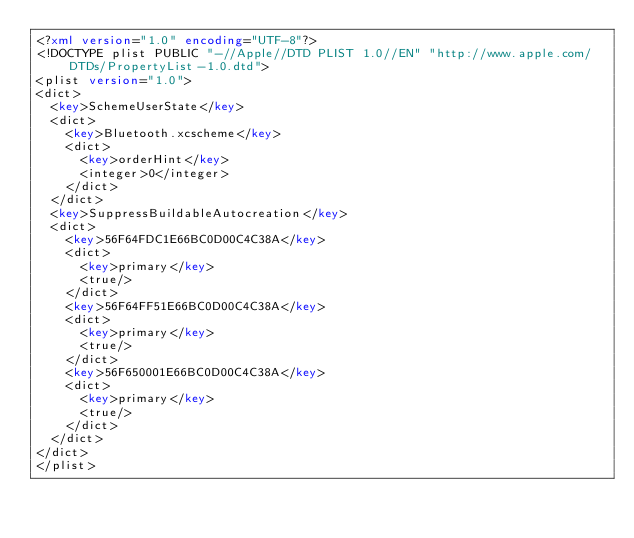<code> <loc_0><loc_0><loc_500><loc_500><_XML_><?xml version="1.0" encoding="UTF-8"?>
<!DOCTYPE plist PUBLIC "-//Apple//DTD PLIST 1.0//EN" "http://www.apple.com/DTDs/PropertyList-1.0.dtd">
<plist version="1.0">
<dict>
	<key>SchemeUserState</key>
	<dict>
		<key>Bluetooth.xcscheme</key>
		<dict>
			<key>orderHint</key>
			<integer>0</integer>
		</dict>
	</dict>
	<key>SuppressBuildableAutocreation</key>
	<dict>
		<key>56F64FDC1E66BC0D00C4C38A</key>
		<dict>
			<key>primary</key>
			<true/>
		</dict>
		<key>56F64FF51E66BC0D00C4C38A</key>
		<dict>
			<key>primary</key>
			<true/>
		</dict>
		<key>56F650001E66BC0D00C4C38A</key>
		<dict>
			<key>primary</key>
			<true/>
		</dict>
	</dict>
</dict>
</plist>
</code> 